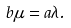<formula> <loc_0><loc_0><loc_500><loc_500>b \mu = a \lambda .</formula> 